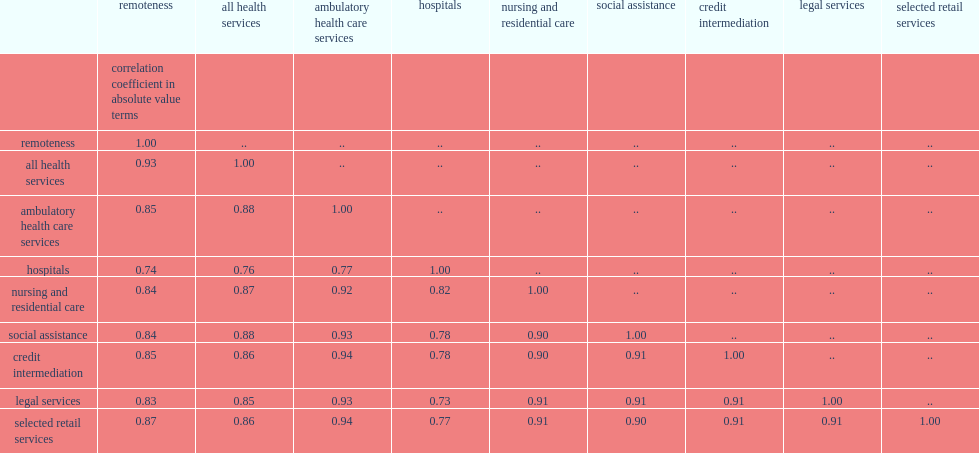What the lowest correlation did hospital services have with the remoteness index? 0.74. What the highest correlation did retial services have with the remoteness index? 0.87. 